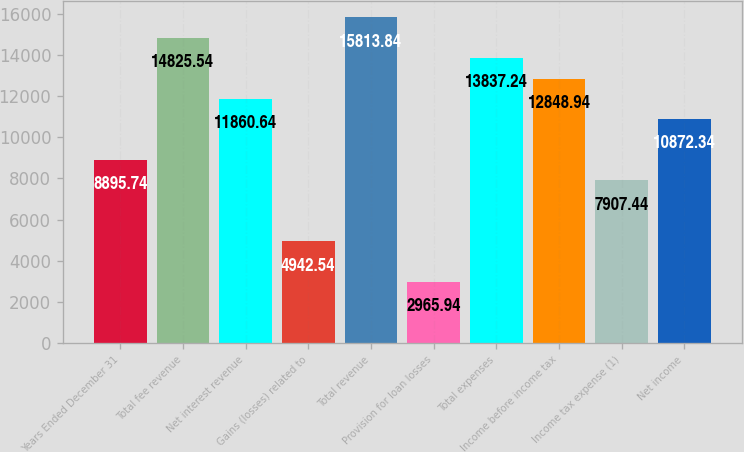Convert chart. <chart><loc_0><loc_0><loc_500><loc_500><bar_chart><fcel>Years Ended December 31<fcel>Total fee revenue<fcel>Net interest revenue<fcel>Gains (losses) related to<fcel>Total revenue<fcel>Provision for loan losses<fcel>Total expenses<fcel>Income before income tax<fcel>Income tax expense (1)<fcel>Net income<nl><fcel>8895.74<fcel>14825.5<fcel>11860.6<fcel>4942.54<fcel>15813.8<fcel>2965.94<fcel>13837.2<fcel>12848.9<fcel>7907.44<fcel>10872.3<nl></chart> 